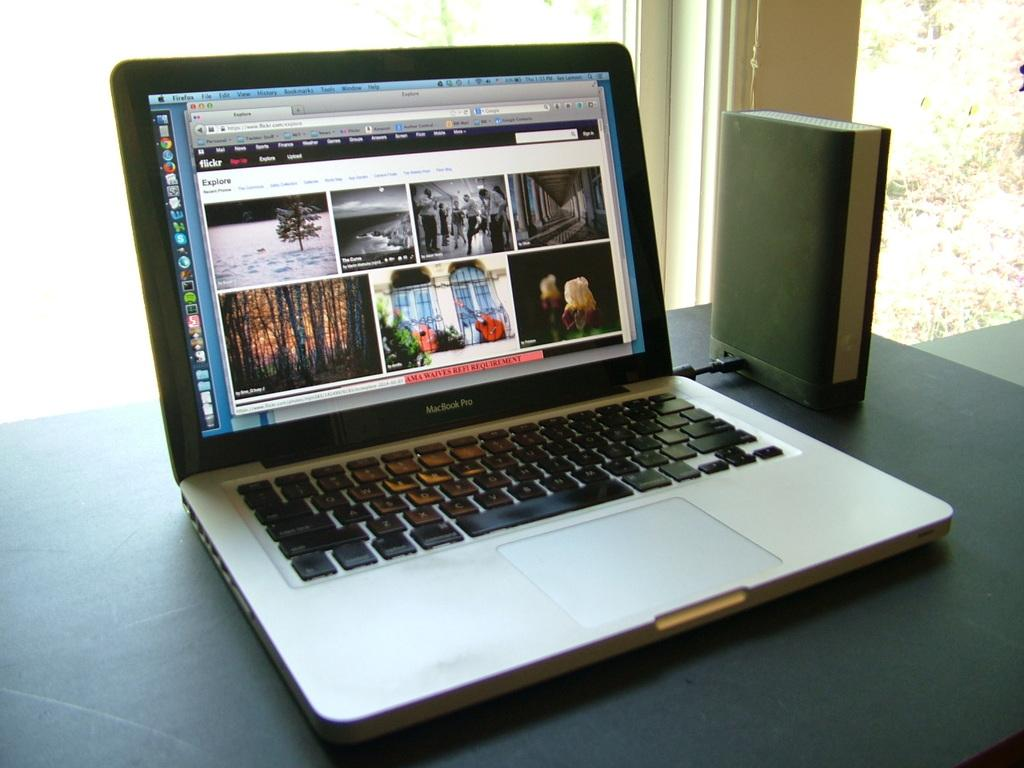Provide a one-sentence caption for the provided image. Flickr Explore is the header of the web site on this laptop. 